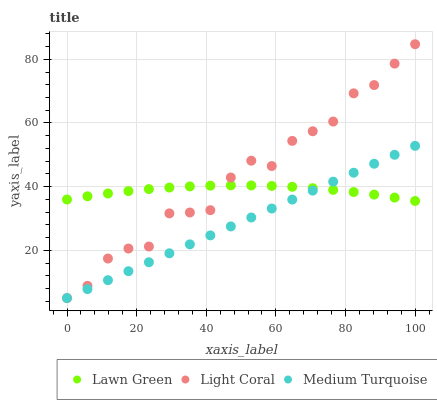Does Medium Turquoise have the minimum area under the curve?
Answer yes or no. Yes. Does Light Coral have the maximum area under the curve?
Answer yes or no. Yes. Does Lawn Green have the minimum area under the curve?
Answer yes or no. No. Does Lawn Green have the maximum area under the curve?
Answer yes or no. No. Is Medium Turquoise the smoothest?
Answer yes or no. Yes. Is Light Coral the roughest?
Answer yes or no. Yes. Is Lawn Green the smoothest?
Answer yes or no. No. Is Lawn Green the roughest?
Answer yes or no. No. Does Light Coral have the lowest value?
Answer yes or no. Yes. Does Lawn Green have the lowest value?
Answer yes or no. No. Does Light Coral have the highest value?
Answer yes or no. Yes. Does Medium Turquoise have the highest value?
Answer yes or no. No. Does Light Coral intersect Medium Turquoise?
Answer yes or no. Yes. Is Light Coral less than Medium Turquoise?
Answer yes or no. No. Is Light Coral greater than Medium Turquoise?
Answer yes or no. No. 